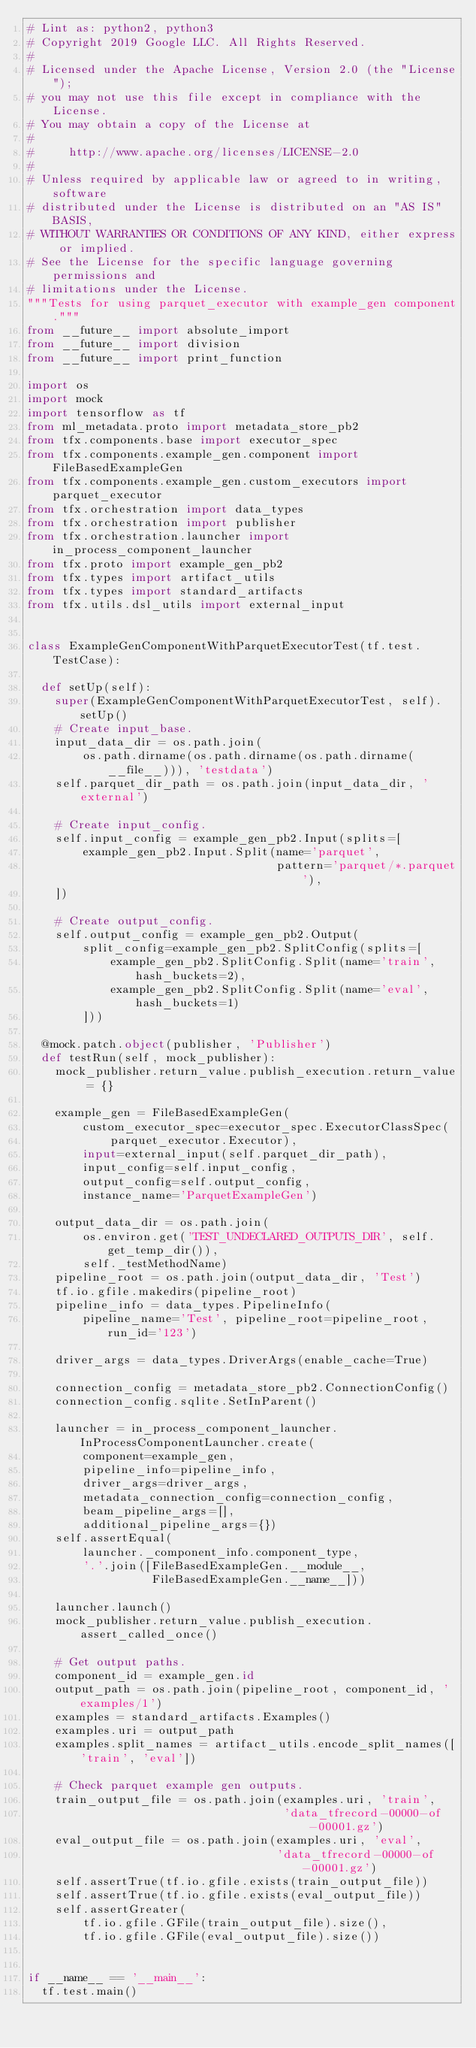Convert code to text. <code><loc_0><loc_0><loc_500><loc_500><_Python_># Lint as: python2, python3
# Copyright 2019 Google LLC. All Rights Reserved.
#
# Licensed under the Apache License, Version 2.0 (the "License");
# you may not use this file except in compliance with the License.
# You may obtain a copy of the License at
#
#     http://www.apache.org/licenses/LICENSE-2.0
#
# Unless required by applicable law or agreed to in writing, software
# distributed under the License is distributed on an "AS IS" BASIS,
# WITHOUT WARRANTIES OR CONDITIONS OF ANY KIND, either express or implied.
# See the License for the specific language governing permissions and
# limitations under the License.
"""Tests for using parquet_executor with example_gen component."""
from __future__ import absolute_import
from __future__ import division
from __future__ import print_function

import os
import mock
import tensorflow as tf
from ml_metadata.proto import metadata_store_pb2
from tfx.components.base import executor_spec
from tfx.components.example_gen.component import FileBasedExampleGen
from tfx.components.example_gen.custom_executors import parquet_executor
from tfx.orchestration import data_types
from tfx.orchestration import publisher
from tfx.orchestration.launcher import in_process_component_launcher
from tfx.proto import example_gen_pb2
from tfx.types import artifact_utils
from tfx.types import standard_artifacts
from tfx.utils.dsl_utils import external_input


class ExampleGenComponentWithParquetExecutorTest(tf.test.TestCase):

  def setUp(self):
    super(ExampleGenComponentWithParquetExecutorTest, self).setUp()
    # Create input_base.
    input_data_dir = os.path.join(
        os.path.dirname(os.path.dirname(os.path.dirname(__file__))), 'testdata')
    self.parquet_dir_path = os.path.join(input_data_dir, 'external')

    # Create input_config.
    self.input_config = example_gen_pb2.Input(splits=[
        example_gen_pb2.Input.Split(name='parquet',
                                    pattern='parquet/*.parquet'),
    ])

    # Create output_config.
    self.output_config = example_gen_pb2.Output(
        split_config=example_gen_pb2.SplitConfig(splits=[
            example_gen_pb2.SplitConfig.Split(name='train', hash_buckets=2),
            example_gen_pb2.SplitConfig.Split(name='eval', hash_buckets=1)
        ]))

  @mock.patch.object(publisher, 'Publisher')
  def testRun(self, mock_publisher):
    mock_publisher.return_value.publish_execution.return_value = {}

    example_gen = FileBasedExampleGen(
        custom_executor_spec=executor_spec.ExecutorClassSpec(
            parquet_executor.Executor),
        input=external_input(self.parquet_dir_path),
        input_config=self.input_config,
        output_config=self.output_config,
        instance_name='ParquetExampleGen')

    output_data_dir = os.path.join(
        os.environ.get('TEST_UNDECLARED_OUTPUTS_DIR', self.get_temp_dir()),
        self._testMethodName)
    pipeline_root = os.path.join(output_data_dir, 'Test')
    tf.io.gfile.makedirs(pipeline_root)
    pipeline_info = data_types.PipelineInfo(
        pipeline_name='Test', pipeline_root=pipeline_root, run_id='123')

    driver_args = data_types.DriverArgs(enable_cache=True)

    connection_config = metadata_store_pb2.ConnectionConfig()
    connection_config.sqlite.SetInParent()

    launcher = in_process_component_launcher.InProcessComponentLauncher.create(
        component=example_gen,
        pipeline_info=pipeline_info,
        driver_args=driver_args,
        metadata_connection_config=connection_config,
        beam_pipeline_args=[],
        additional_pipeline_args={})
    self.assertEqual(
        launcher._component_info.component_type,
        '.'.join([FileBasedExampleGen.__module__,
                  FileBasedExampleGen.__name__]))

    launcher.launch()
    mock_publisher.return_value.publish_execution.assert_called_once()

    # Get output paths.
    component_id = example_gen.id
    output_path = os.path.join(pipeline_root, component_id, 'examples/1')
    examples = standard_artifacts.Examples()
    examples.uri = output_path
    examples.split_names = artifact_utils.encode_split_names(['train', 'eval'])

    # Check parquet example gen outputs.
    train_output_file = os.path.join(examples.uri, 'train',
                                     'data_tfrecord-00000-of-00001.gz')
    eval_output_file = os.path.join(examples.uri, 'eval',
                                    'data_tfrecord-00000-of-00001.gz')
    self.assertTrue(tf.io.gfile.exists(train_output_file))
    self.assertTrue(tf.io.gfile.exists(eval_output_file))
    self.assertGreater(
        tf.io.gfile.GFile(train_output_file).size(),
        tf.io.gfile.GFile(eval_output_file).size())


if __name__ == '__main__':
  tf.test.main()
</code> 